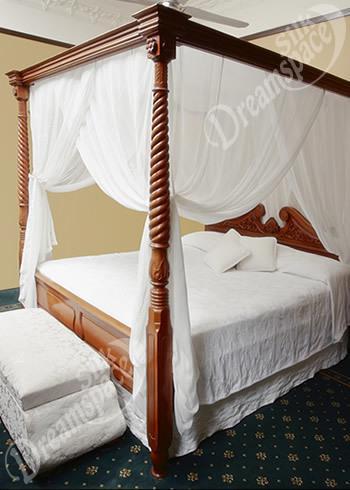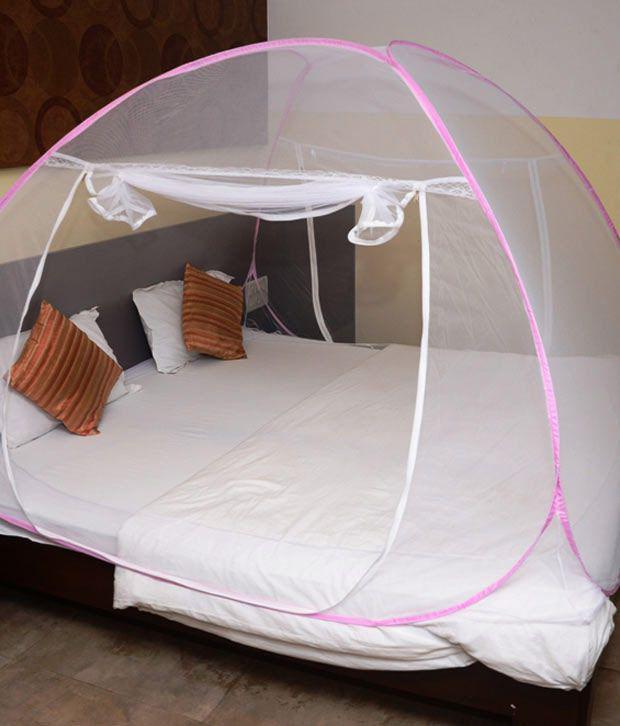The first image is the image on the left, the second image is the image on the right. Given the left and right images, does the statement "The right image shows a dome-shaped bed enclosure." hold true? Answer yes or no. Yes. 